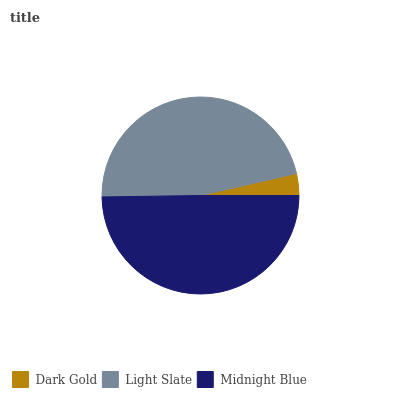Is Dark Gold the minimum?
Answer yes or no. Yes. Is Midnight Blue the maximum?
Answer yes or no. Yes. Is Light Slate the minimum?
Answer yes or no. No. Is Light Slate the maximum?
Answer yes or no. No. Is Light Slate greater than Dark Gold?
Answer yes or no. Yes. Is Dark Gold less than Light Slate?
Answer yes or no. Yes. Is Dark Gold greater than Light Slate?
Answer yes or no. No. Is Light Slate less than Dark Gold?
Answer yes or no. No. Is Light Slate the high median?
Answer yes or no. Yes. Is Light Slate the low median?
Answer yes or no. Yes. Is Midnight Blue the high median?
Answer yes or no. No. Is Dark Gold the low median?
Answer yes or no. No. 